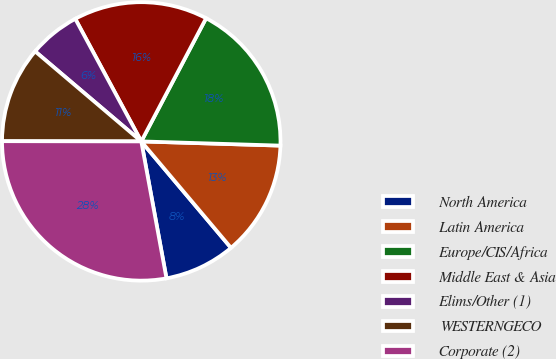Convert chart. <chart><loc_0><loc_0><loc_500><loc_500><pie_chart><fcel>North America<fcel>Latin America<fcel>Europe/CIS/Africa<fcel>Middle East & Asia<fcel>Elims/Other (1)<fcel>WESTERNGECO<fcel>Corporate (2)<nl><fcel>8.25%<fcel>13.37%<fcel>17.77%<fcel>15.57%<fcel>5.94%<fcel>11.17%<fcel>27.92%<nl></chart> 